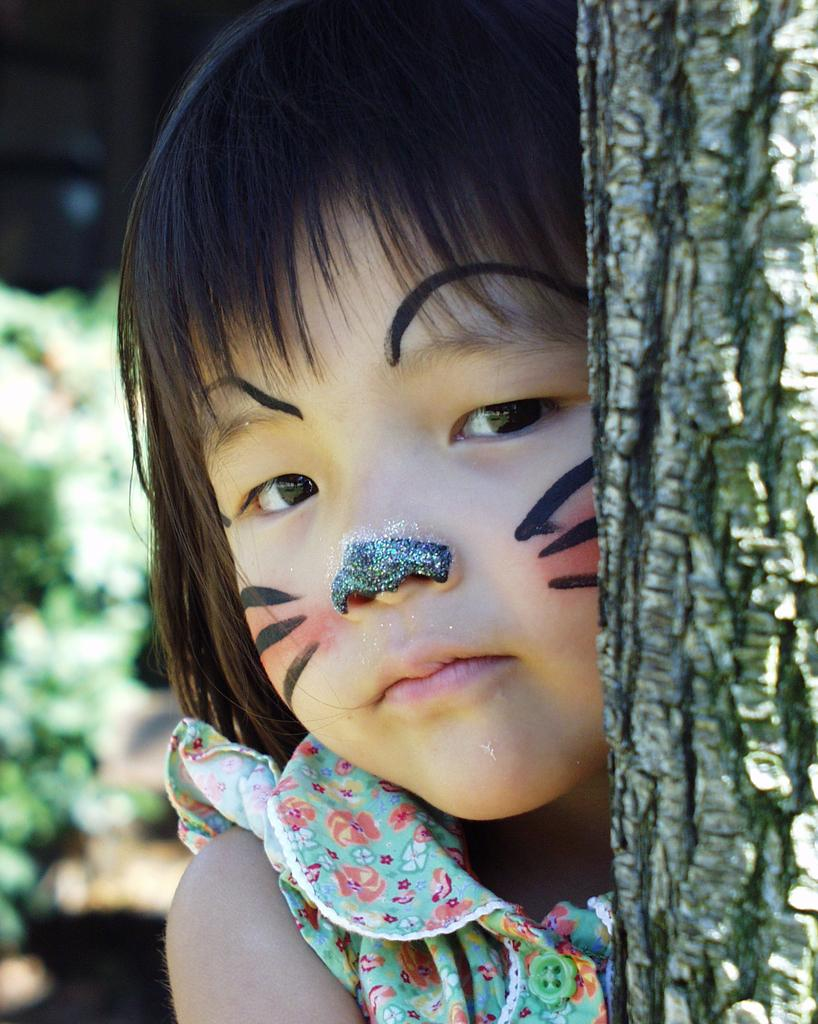Who is in the picture? There is a girl in the picture. What is unique about the girl's appearance? The girl is wearing face painting. What natural element can be seen in the picture? There is a tree trunk in the picture. What type of necklace is the girl wearing in the picture? There is no necklace mentioned or visible in the image. 